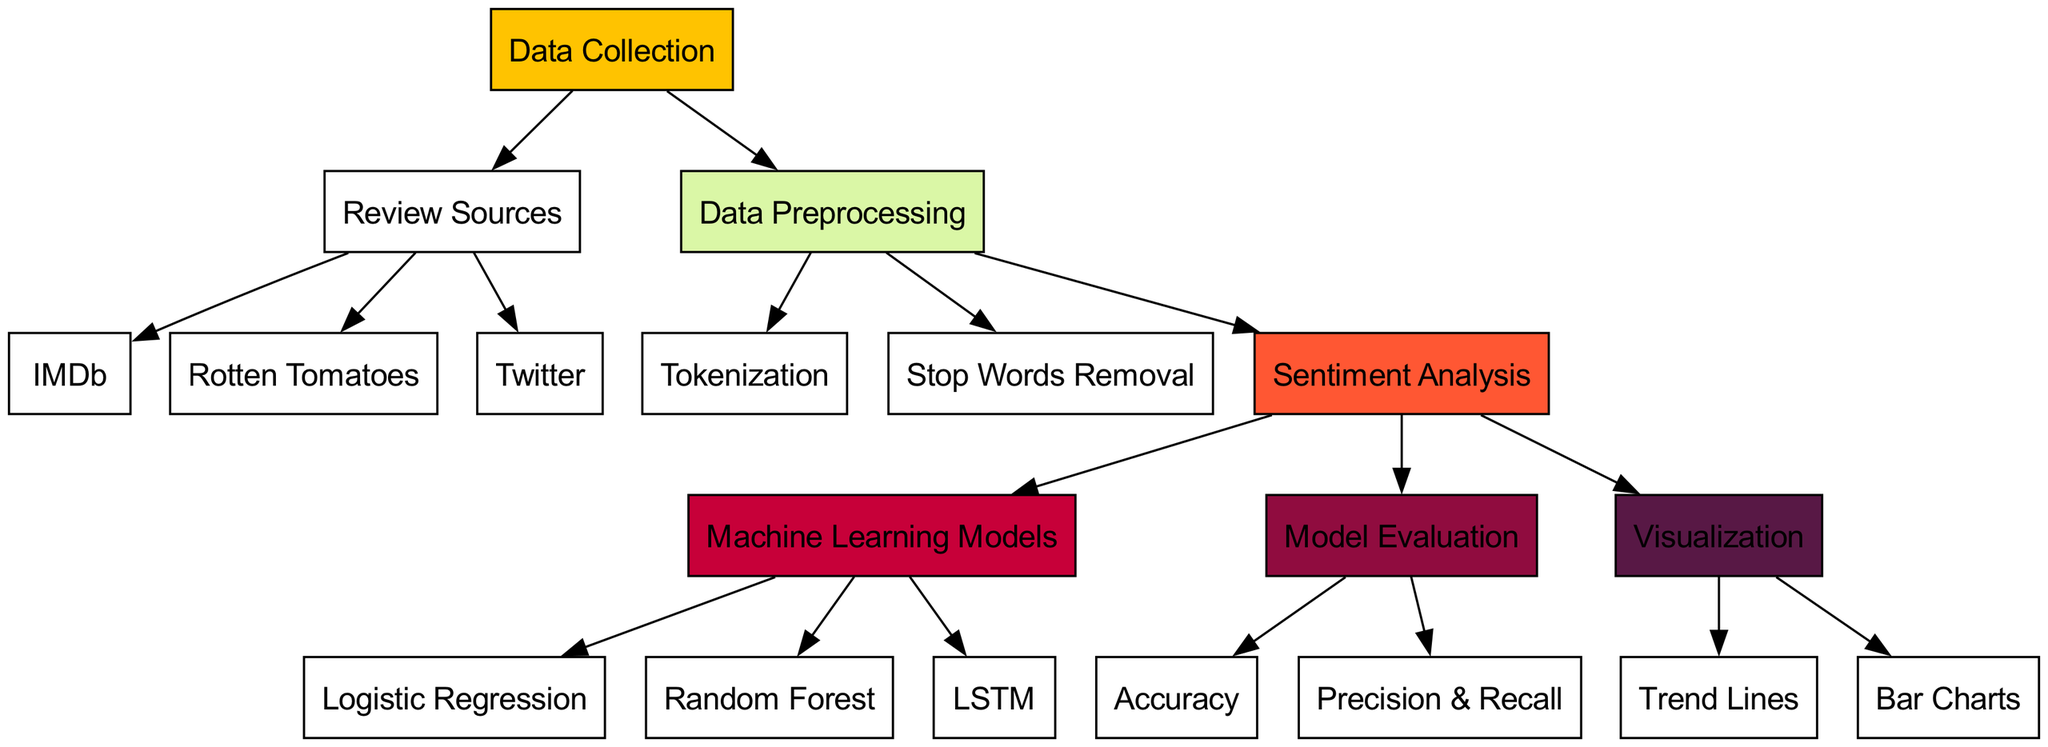What are the three sources of movie reviews listed in the diagram? The diagram has three specific review sources identified under the "Review Sources" node: IMDb, Rotten Tomatoes, and Twitter.
Answer: IMDb, Rotten Tomatoes, Twitter How many nodes are there in the diagram? The diagram contains a total of 17 nodes that represent various aspects of the sentiment analysis process, from data collection to visualization.
Answer: 17 What type of machine learning model is represented as "LSTM"? The diagram identifies "LSTM" as one of the machine learning models used for sentiment analysis.
Answer: LSTM Which step comes after "Data Preprocessing"? Following the "Data Preprocessing" step, the diagram indicates that the next step is "Sentiment Analysis."
Answer: Sentiment Analysis What method is shown as the last evaluation metric in the "Evaluation" step? The last evaluation metric represented in the "Evaluation" section is "Precision & Recall," completing the assessment of the model's performance.
Answer: Precision & Recall How many edges are directed from "Sentiment Analysis" to other nodes? In the diagram, "Sentiment Analysis" has three outgoing edges that connect it to "MLModels," "Evaluation," and "Visualization," indicating important processes stemming from sentiment analysis.
Answer: 3 What node represents the step focusing on removing unnecessary words? The node labeled "Stop Words Removal" signifies the step dedicated to eliminating unnecessary words during the preprocessing phase.
Answer: Stop Words Removal Which visualization techniques are utilized in the diagram? The diagram specifies two visualization techniques: "Trend Lines" and "Bar Charts" that are used to represent sentiment analysis results graphically.
Answer: Trend Lines, Bar Charts What is the first step in the machine learning pipeline shown? The first step in the machine learning pipeline as presented in the diagram is "Data Collection," which initiates the sentiment analysis process.
Answer: Data Collection 